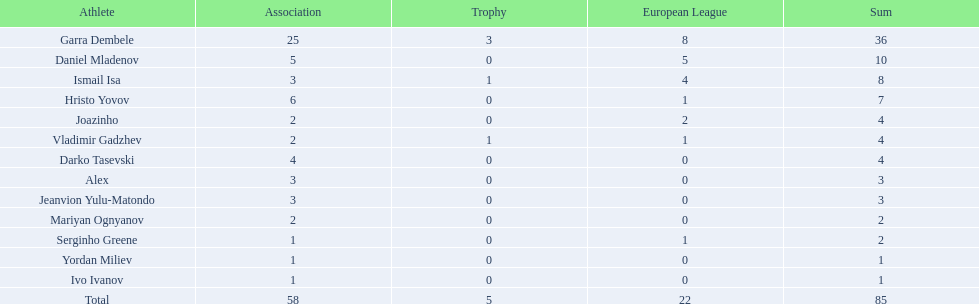How many of the players did not score any goals in the cup? 10. 